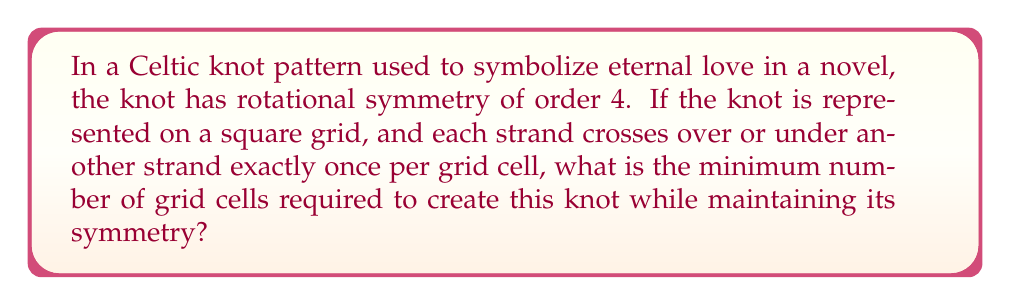Can you solve this math problem? Let's approach this step-by-step:

1) Rotational symmetry of order 4 means the knot looks the same after rotating 90°, 180°, 270°, and 360°.

2) For a Celtic knot on a square grid, this symmetry implies the grid must be square, with dimensions $n \times n$.

3) Each strand must cross over or under another strand once per cell. This means each cell contains exactly one crossing.

4) For the knot to close and maintain symmetry, the number of crossings along any path from the center to an edge must be odd. This ensures the strand alternates between over and under crossings.

5) The minimum non-trivial odd number is 3. So, the minimum distance from the center to an edge must be 3 cells.

6) In a square grid, this means we need at least 3 cells from the center to each edge, plus the central cell.

7) Therefore, the minimum dimension of the grid is:
   $$(3 \text{ cells to edge} + 1 \text{ central cell}) \times 2 \text{ (for both sides)} - 1 \text{ (to avoid double-counting the central cell)} = 7$$

8) The minimum number of grid cells is thus:

   $$7 \times 7 = 49$$

This 7x7 grid is the smallest that can accommodate a rotationally symmetric Celtic knot of order 4 while ensuring each cell contains exactly one crossing.
Answer: 49 